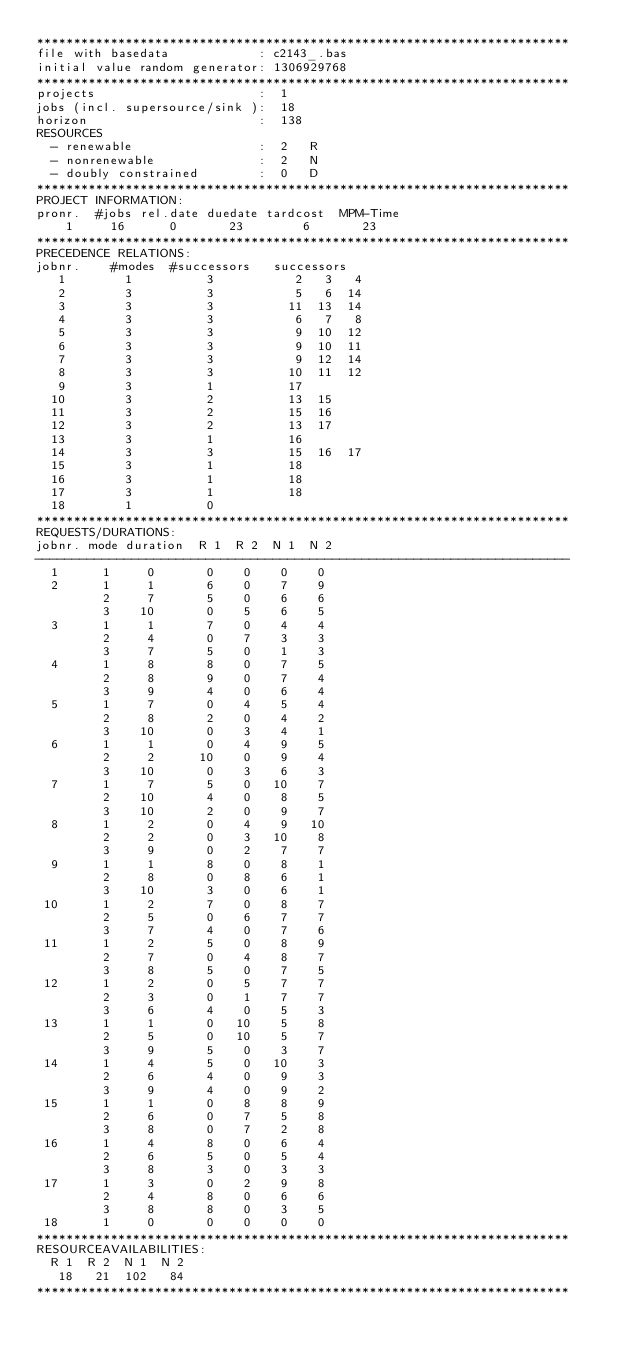<code> <loc_0><loc_0><loc_500><loc_500><_ObjectiveC_>************************************************************************
file with basedata            : c2143_.bas
initial value random generator: 1306929768
************************************************************************
projects                      :  1
jobs (incl. supersource/sink ):  18
horizon                       :  138
RESOURCES
  - renewable                 :  2   R
  - nonrenewable              :  2   N
  - doubly constrained        :  0   D
************************************************************************
PROJECT INFORMATION:
pronr.  #jobs rel.date duedate tardcost  MPM-Time
    1     16      0       23        6       23
************************************************************************
PRECEDENCE RELATIONS:
jobnr.    #modes  #successors   successors
   1        1          3           2   3   4
   2        3          3           5   6  14
   3        3          3          11  13  14
   4        3          3           6   7   8
   5        3          3           9  10  12
   6        3          3           9  10  11
   7        3          3           9  12  14
   8        3          3          10  11  12
   9        3          1          17
  10        3          2          13  15
  11        3          2          15  16
  12        3          2          13  17
  13        3          1          16
  14        3          3          15  16  17
  15        3          1          18
  16        3          1          18
  17        3          1          18
  18        1          0        
************************************************************************
REQUESTS/DURATIONS:
jobnr. mode duration  R 1  R 2  N 1  N 2
------------------------------------------------------------------------
  1      1     0       0    0    0    0
  2      1     1       6    0    7    9
         2     7       5    0    6    6
         3    10       0    5    6    5
  3      1     1       7    0    4    4
         2     4       0    7    3    3
         3     7       5    0    1    3
  4      1     8       8    0    7    5
         2     8       9    0    7    4
         3     9       4    0    6    4
  5      1     7       0    4    5    4
         2     8       2    0    4    2
         3    10       0    3    4    1
  6      1     1       0    4    9    5
         2     2      10    0    9    4
         3    10       0    3    6    3
  7      1     7       5    0   10    7
         2    10       4    0    8    5
         3    10       2    0    9    7
  8      1     2       0    4    9   10
         2     2       0    3   10    8
         3     9       0    2    7    7
  9      1     1       8    0    8    1
         2     8       0    8    6    1
         3    10       3    0    6    1
 10      1     2       7    0    8    7
         2     5       0    6    7    7
         3     7       4    0    7    6
 11      1     2       5    0    8    9
         2     7       0    4    8    7
         3     8       5    0    7    5
 12      1     2       0    5    7    7
         2     3       0    1    7    7
         3     6       4    0    5    3
 13      1     1       0   10    5    8
         2     5       0   10    5    7
         3     9       5    0    3    7
 14      1     4       5    0   10    3
         2     6       4    0    9    3
         3     9       4    0    9    2
 15      1     1       0    8    8    9
         2     6       0    7    5    8
         3     8       0    7    2    8
 16      1     4       8    0    6    4
         2     6       5    0    5    4
         3     8       3    0    3    3
 17      1     3       0    2    9    8
         2     4       8    0    6    6
         3     8       8    0    3    5
 18      1     0       0    0    0    0
************************************************************************
RESOURCEAVAILABILITIES:
  R 1  R 2  N 1  N 2
   18   21  102   84
************************************************************************
</code> 